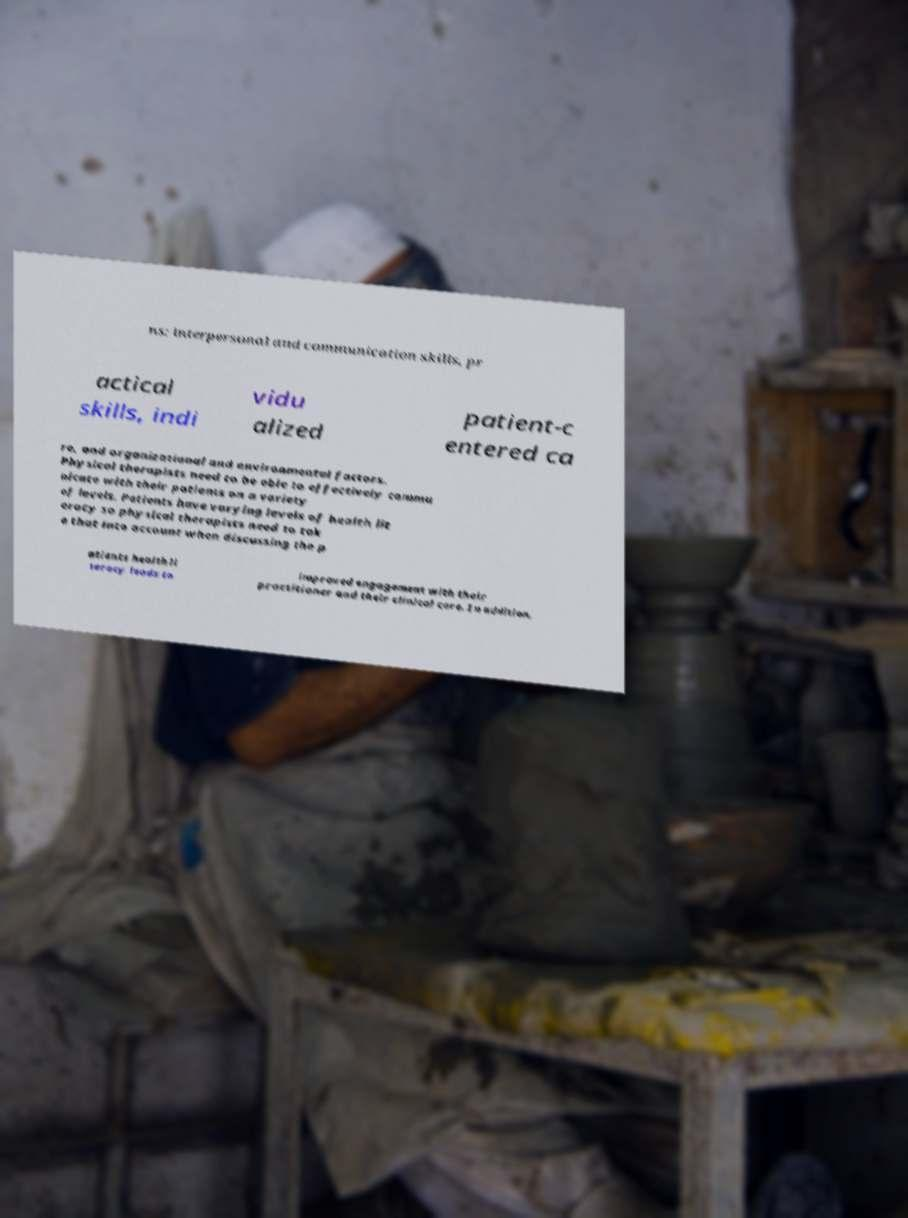Could you assist in decoding the text presented in this image and type it out clearly? ns: interpersonal and communication skills, pr actical skills, indi vidu alized patient-c entered ca re, and organizational and environmental factors. Physical therapists need to be able to effectively commu nicate with their patients on a variety of levels. Patients have varying levels of health lit eracy so physical therapists need to tak e that into account when discussing the p atients health li teracy leads to improved engagement with their practitioner and their clinical care. In addition, 